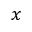<formula> <loc_0><loc_0><loc_500><loc_500>x</formula> 